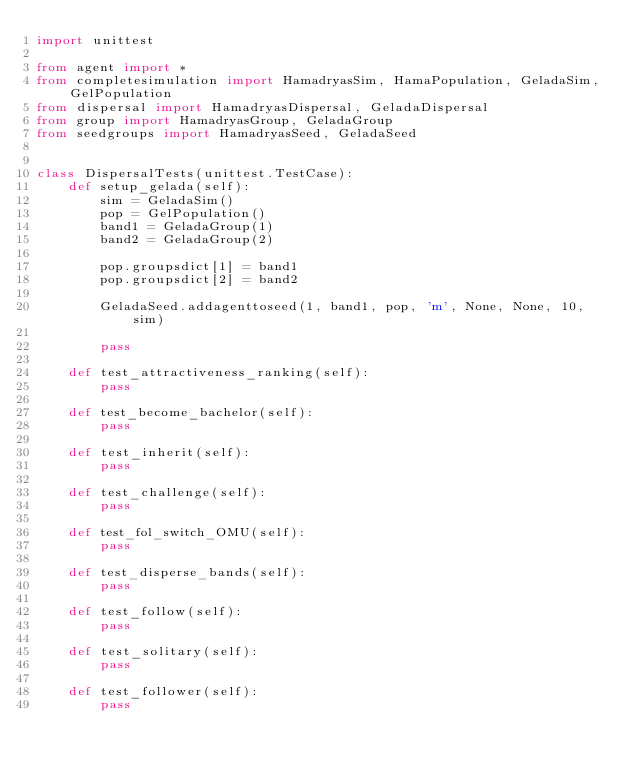Convert code to text. <code><loc_0><loc_0><loc_500><loc_500><_Python_>import unittest

from agent import *
from completesimulation import HamadryasSim, HamaPopulation, GeladaSim, GelPopulation
from dispersal import HamadryasDispersal, GeladaDispersal
from group import HamadryasGroup, GeladaGroup
from seedgroups import HamadryasSeed, GeladaSeed


class DispersalTests(unittest.TestCase):
    def setup_gelada(self):
        sim = GeladaSim()
        pop = GelPopulation()
        band1 = GeladaGroup(1)
        band2 = GeladaGroup(2)

        pop.groupsdict[1] = band1
        pop.groupsdict[2] = band2

        GeladaSeed.addagenttoseed(1, band1, pop, 'm', None, None, 10, sim)

        pass

    def test_attractiveness_ranking(self):
        pass

    def test_become_bachelor(self):
        pass

    def test_inherit(self):
        pass

    def test_challenge(self):
        pass

    def test_fol_switch_OMU(self):
        pass

    def test_disperse_bands(self):
        pass

    def test_follow(self):
        pass

    def test_solitary(self):
        pass

    def test_follower(self):
        pass
</code> 